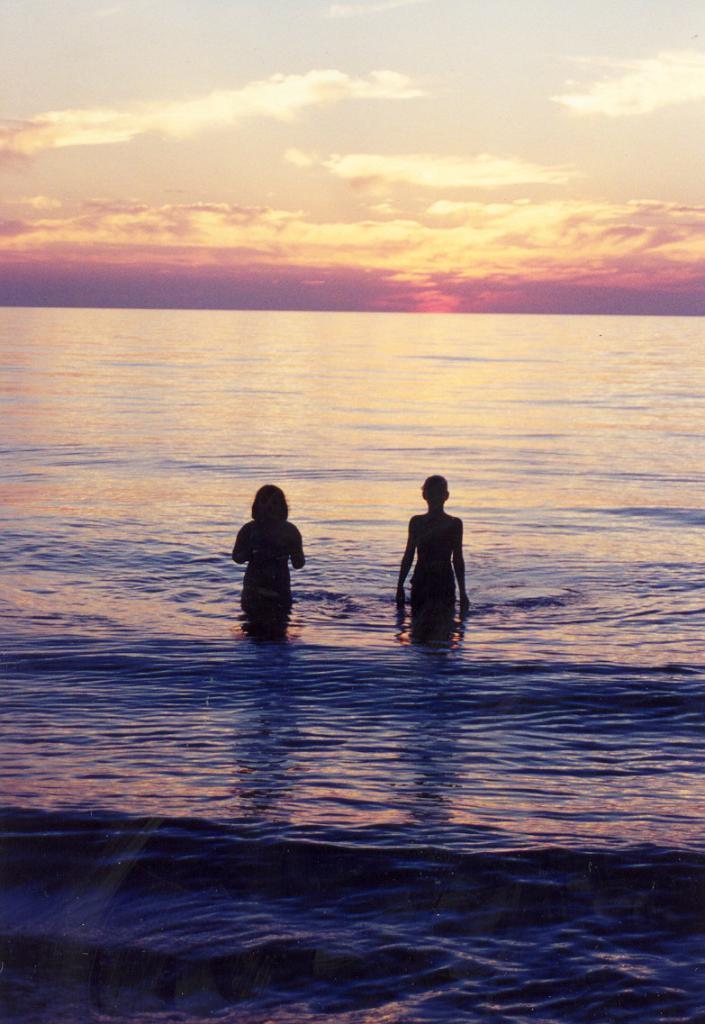Describe this image in one or two sentences. In this image we can see two persons are standing in the water, at above here is the sky in orange and white color. 